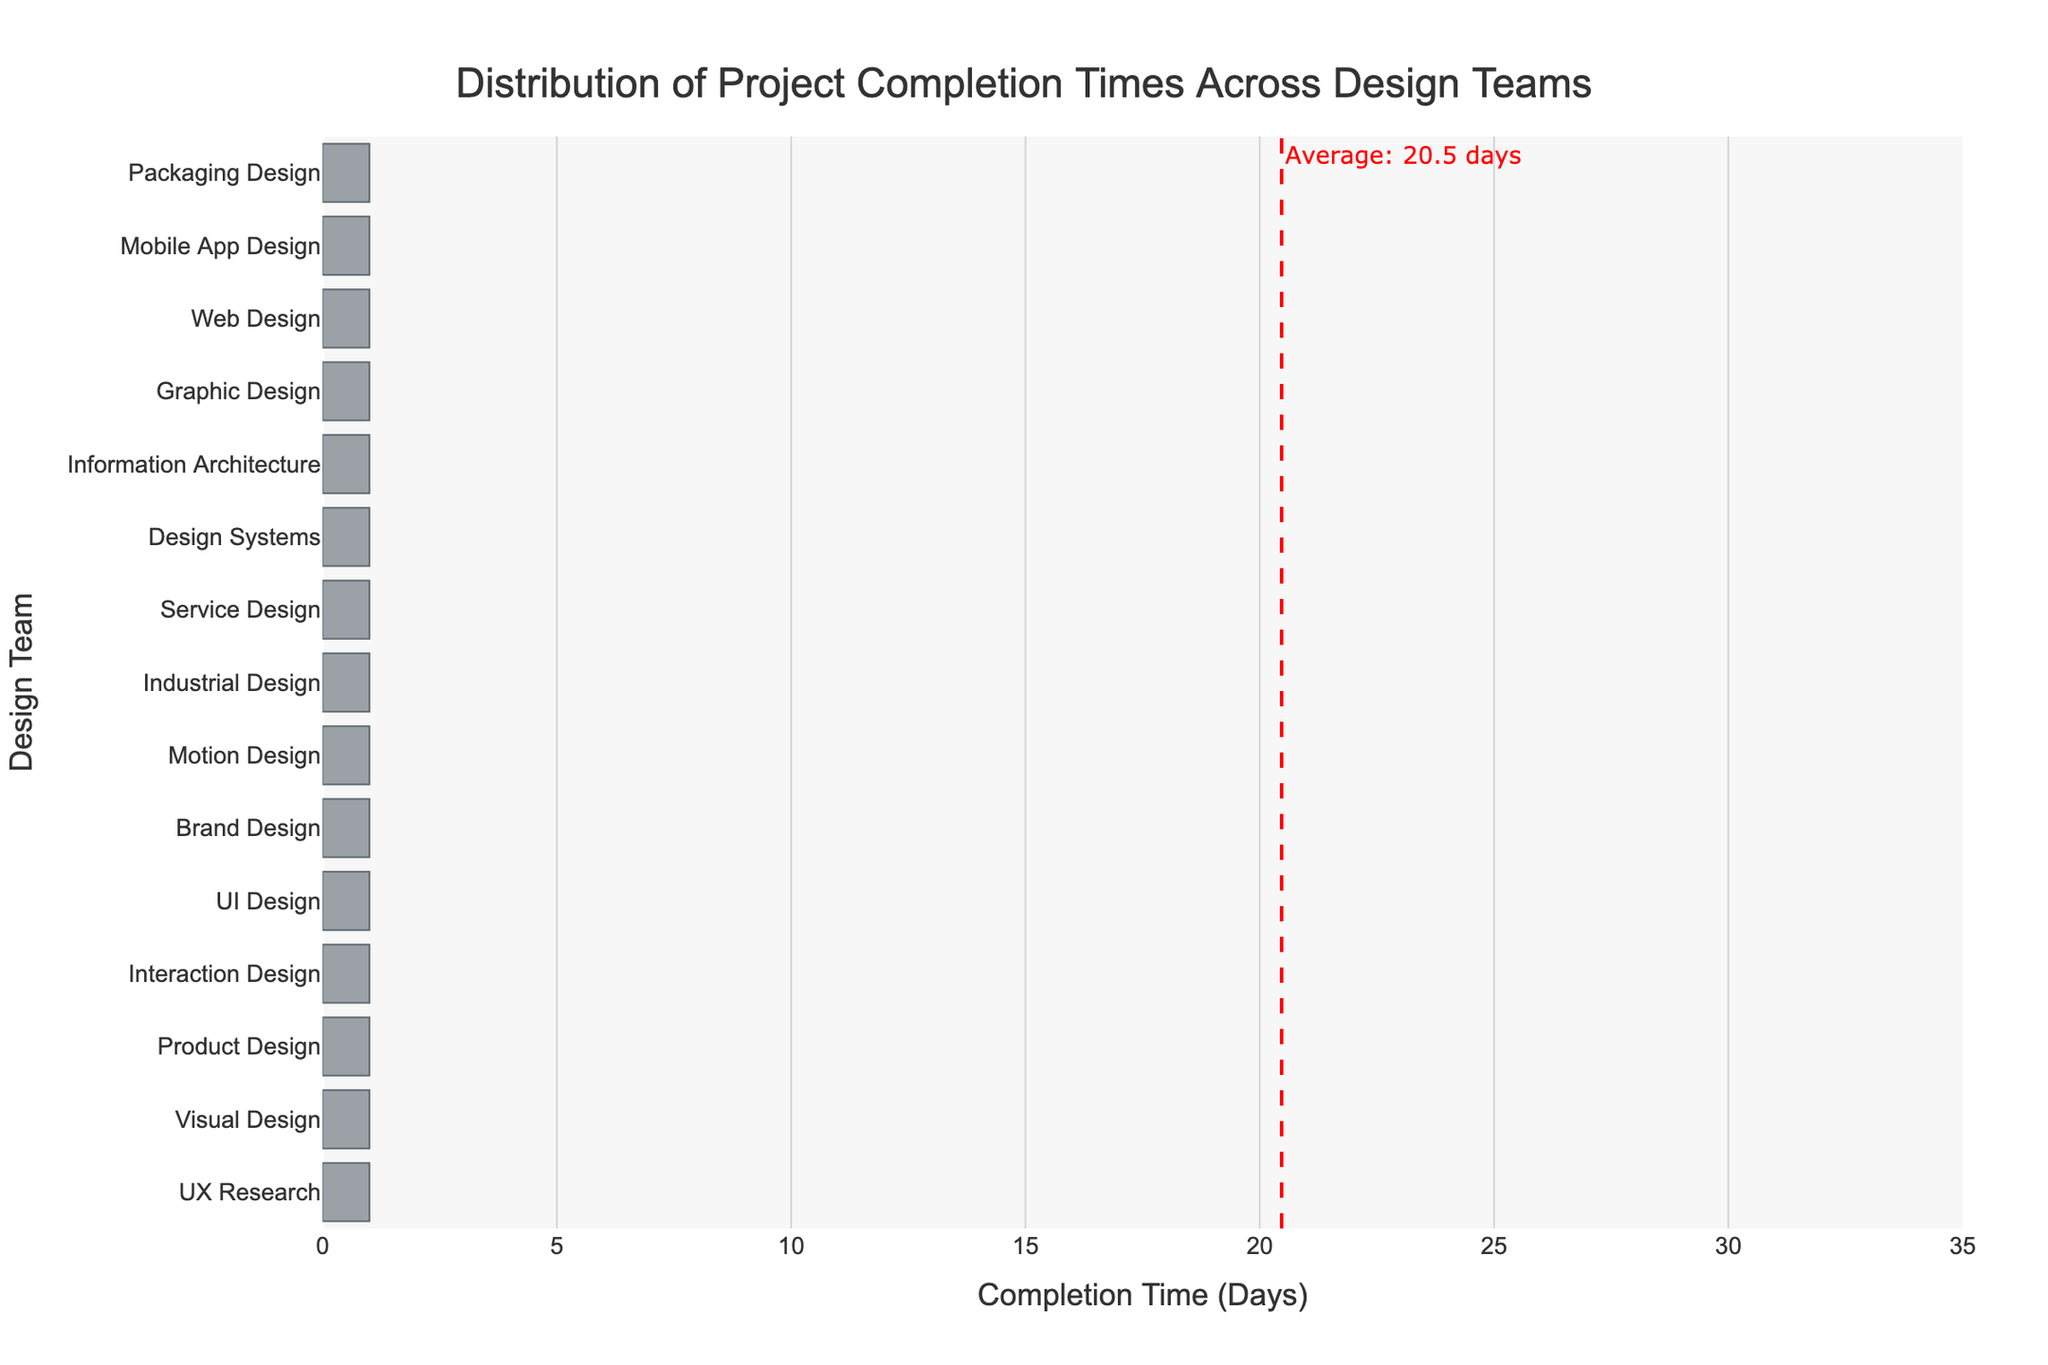What is the title of the histogram? The title is typically displayed at the top of the figure. In this case, it should be visible at the top center of the histogram plot.
Answer: Distribution of Project Completion Times Across Design Teams What is the design team with the longest average project completion time? By examining the histogram, identify the bar that extends the farthest to the right. This bar represents the design team with the longest project completion time.
Answer: Industrial Design How many design teams have a project completion time less than 20 days? Count the bars that fall within the range of less than 20 days on the horizontal axis. The bars represent different design teams.
Answer: 5 What is the average completion time represented by the red dashed line? Look for the red dashed vertical line on the histogram, which indicates the average completion time. The annotation next to the line provides the exact value.
Answer: 20.1 days How many design teams have completion times above the average? Identify the bars that extend past the red dashed vertical average line. Count these bars to find the number of design teams exceeding the average completion time.
Answer: 7 Which design team has a project completion time closest to the average? Find the bar that is closest to the red dashed vertical line representing the average completion time.
Answer: Service Design What is the range of project completion times in the histogram? Examine the histogram to determine the minimum and maximum project completion times, and calculate the difference (range). The minimum is 12 days (Motion Design), and the maximum is 30 days (Industrial Design).
Answer: 18 days Which design team has the shortest project completion time? Identify the bar that is the shortest on the horizontal axis, indicating the design team with the shortest project completion time.
Answer: Motion Design What is the median project completion time among the design teams? Arrange the completion times in ascending order and find the middle value. If there are an odd number of teams, it is the middle value; if even, it is the average of the two middle values.
Answer: 19 days How does the project completion time of Visual Design compare to the average? Compare the bar representing Visual Design to the red dashed vertical line showing the average. Visual Design's completion time should be higher or lower based on bar position relative to the line.
Answer: Higher 